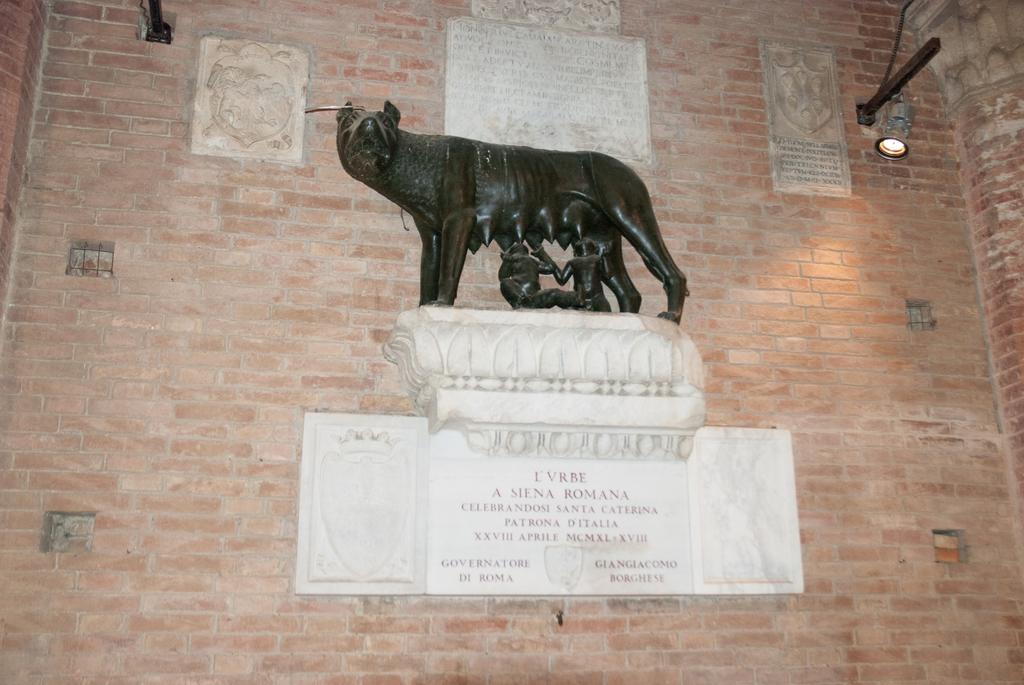What is present on the wall in the image? There is an animal sculpture and a light visible on the wall. Can you describe the animal sculpture? The animal sculpture is on the wall in the image. What type of light is visible on the wall? There is a light visible on the wall in the image. What type of apparel is the rabbit wearing in the image? There is no rabbit present in the image, and therefore no apparel can be observed. What type of needle is being used by the animal sculpture in the image? There is no needle present in the image, and the animal sculpture is not performing any actions that would require a needle. 